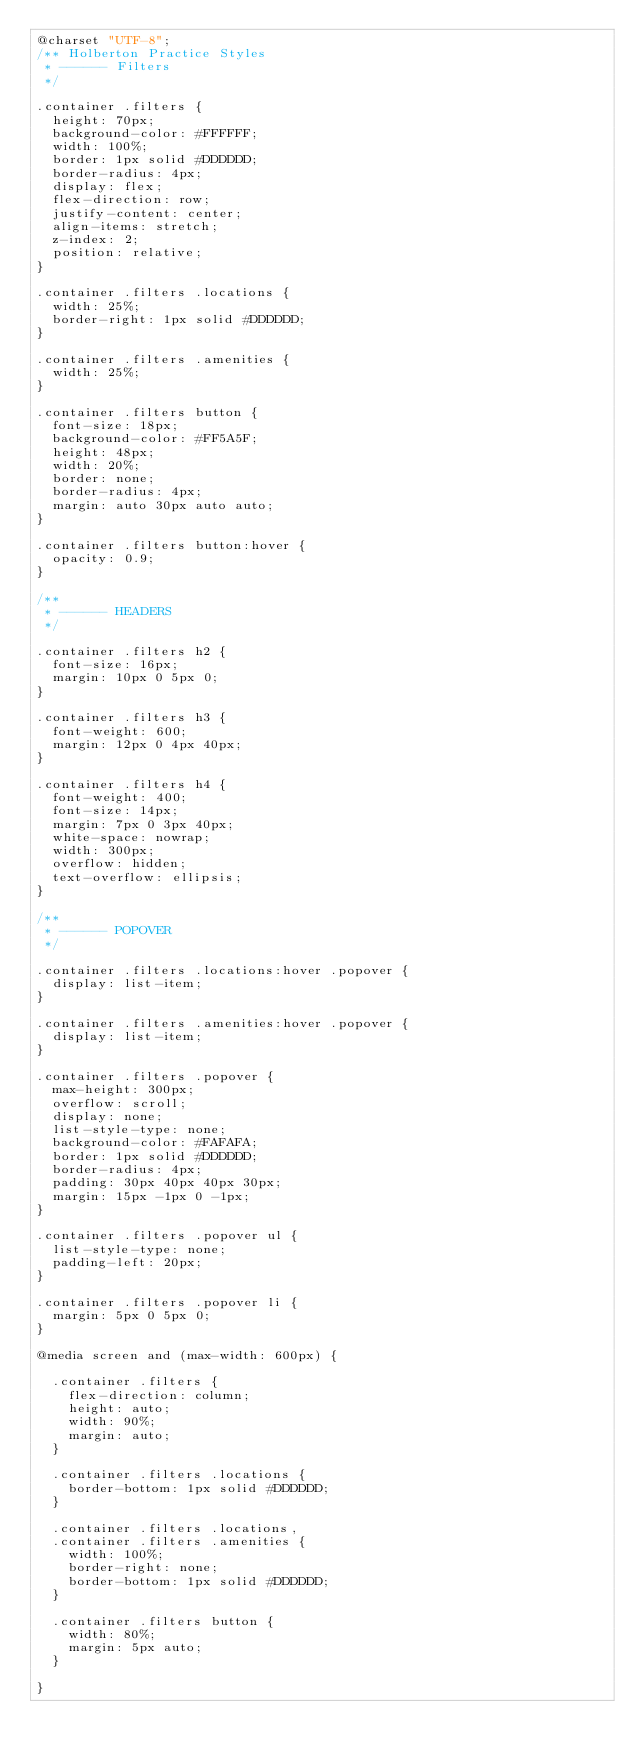<code> <loc_0><loc_0><loc_500><loc_500><_CSS_>@charset "UTF-8";
/** Holberton Practice Styles
 * ------ Filters
 */

.container .filters {
	height: 70px;
	background-color: #FFFFFF;
	width: 100%;
	border: 1px solid #DDDDDD;
	border-radius: 4px;
	display: flex;
	flex-direction: row;
	justify-content: center;
	align-items: stretch;
	z-index: 2;
	position: relative;
}

.container .filters .locations {
	width: 25%;
	border-right: 1px solid #DDDDDD;
}

.container .filters .amenities {
	width: 25%;
}

.container .filters button {
	font-size: 18px;
	background-color: #FF5A5F;
	height: 48px;
	width: 20%;
	border: none;
	border-radius: 4px;
	margin: auto 30px auto auto;
}

.container .filters button:hover {
	opacity: 0.9;
}

/**
 * ------ HEADERS
 */

.container .filters h2 {
	font-size: 16px;
	margin: 10px 0 5px 0;
}

.container .filters h3 {
	font-weight: 600;
	margin: 12px 0 4px 40px;
}

.container .filters h4 {
	font-weight: 400;
	font-size: 14px;
	margin: 7px 0 3px 40px;
	white-space: nowrap;
	width: 300px;
	overflow: hidden;
	text-overflow: ellipsis;
}

/**
 * ------ POPOVER
 */

.container .filters .locations:hover .popover {
	display: list-item;
}

.container .filters .amenities:hover .popover {
	display: list-item;
}

.container .filters .popover {
	max-height: 300px;
	overflow: scroll;
	display: none;
	list-style-type: none;
	background-color: #FAFAFA;
	border: 1px solid #DDDDDD;
	border-radius: 4px;
	padding: 30px 40px 40px 30px;
	margin: 15px -1px 0 -1px;
}

.container .filters .popover ul {
	list-style-type: none;
	padding-left: 20px;
}

.container .filters .popover li {
	margin: 5px 0 5px 0;
}

@media screen and (max-width: 600px) {

	.container .filters {
		flex-direction: column;
		height: auto;
		width: 90%;
		margin: auto;
	}

	.container .filters .locations {
		border-bottom: 1px solid #DDDDDD;
	}

	.container .filters .locations,
	.container .filters .amenities {
		width: 100%;
		border-right: none;
		border-bottom: 1px solid #DDDDDD;
	}

	.container .filters button {
		width: 80%;
		margin: 5px auto;
	}

}
</code> 